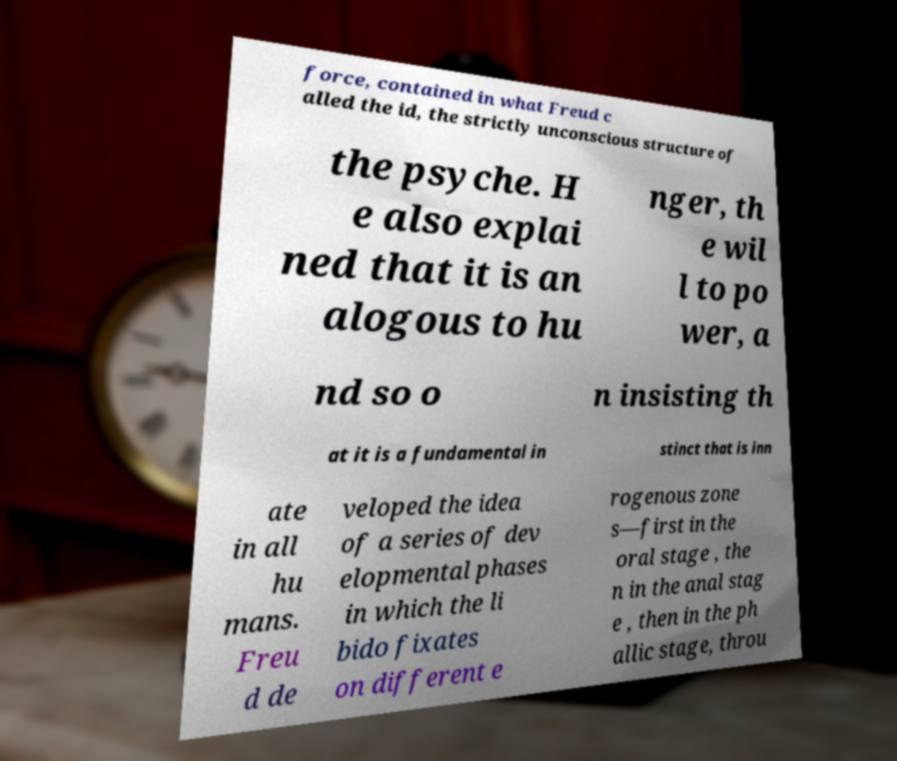For documentation purposes, I need the text within this image transcribed. Could you provide that? force, contained in what Freud c alled the id, the strictly unconscious structure of the psyche. H e also explai ned that it is an alogous to hu nger, th e wil l to po wer, a nd so o n insisting th at it is a fundamental in stinct that is inn ate in all hu mans. Freu d de veloped the idea of a series of dev elopmental phases in which the li bido fixates on different e rogenous zone s—first in the oral stage , the n in the anal stag e , then in the ph allic stage, throu 